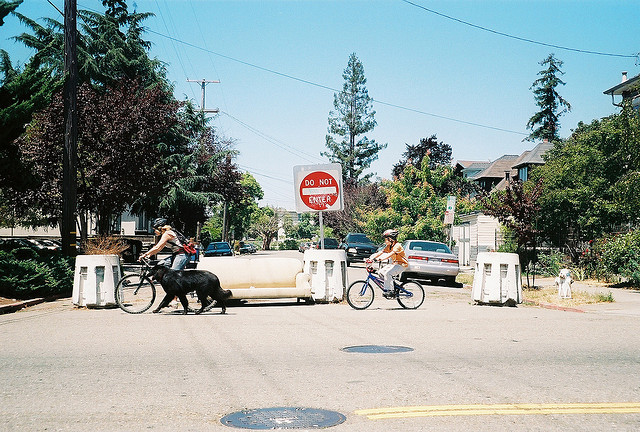Please transcribe the text information in this image. DO NOT ENTER 